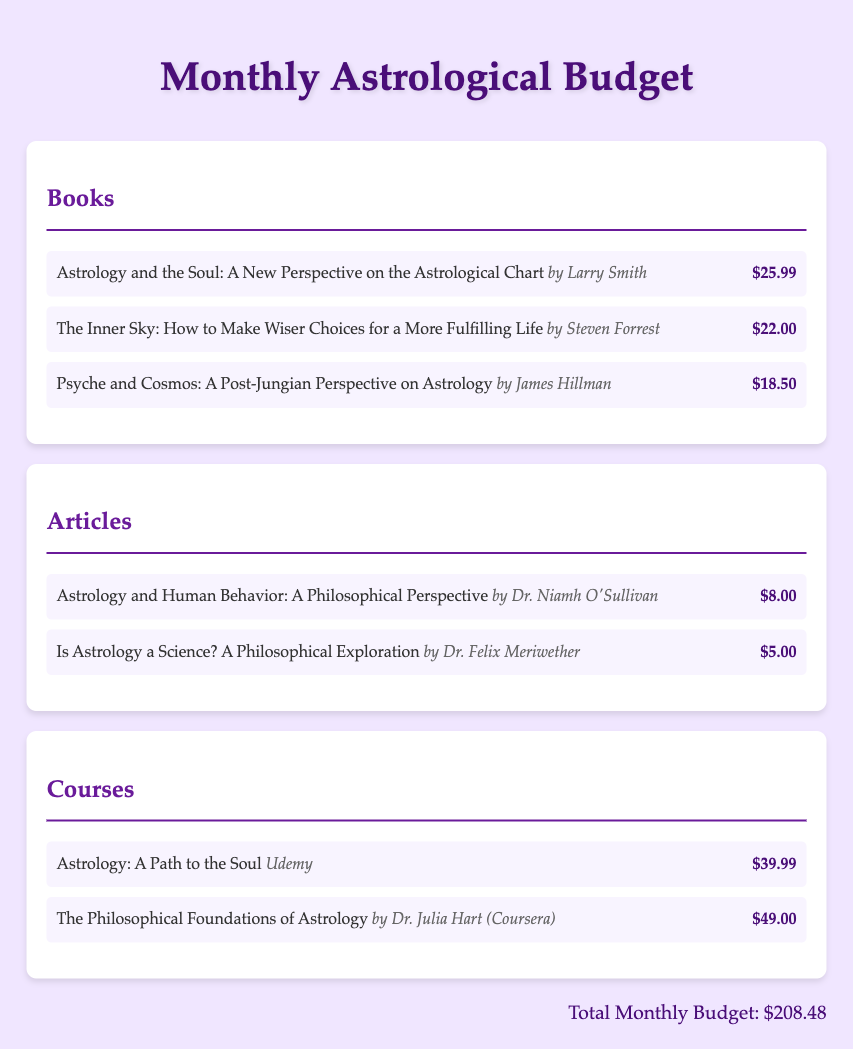What is the title of the first book listed? The title of the first book is presented at the top of the Books section in the document.
Answer: Astrology and the Soul: A New Perspective on the Astrological Chart Who is the author of "The Inner Sky"? The document provides the author's name next to the book title in the Books section.
Answer: Steven Forrest How much does the article by Dr. Niamh O'Sullivan cost? The document specifies the price next to the article title in the Articles section.
Answer: $8.00 What is the total monthly budget? The total is found at the bottom of the document, summarizing all expenses.
Answer: $208.48 Which course is offered by Udemy? The document indicates the course provider next to the course title in the Courses section.
Answer: Astrology: A Path to the Soul What is the price of "Psyche and Cosmos"? The price is listed next to the book title in the Books section.
Answer: $18.50 Who wrote the article titled "Is Astrology a Science?" The author's name is included in the Articles section next to the article title.
Answer: Dr. Felix Meriwether How many courses are listed in the document? The total number of courses can be determined by counting the listed courses in the Courses section.
Answer: 2 What genre do all items in the document relate to? The document indicates a specific thematic focus throughout all sections.
Answer: Astrology 